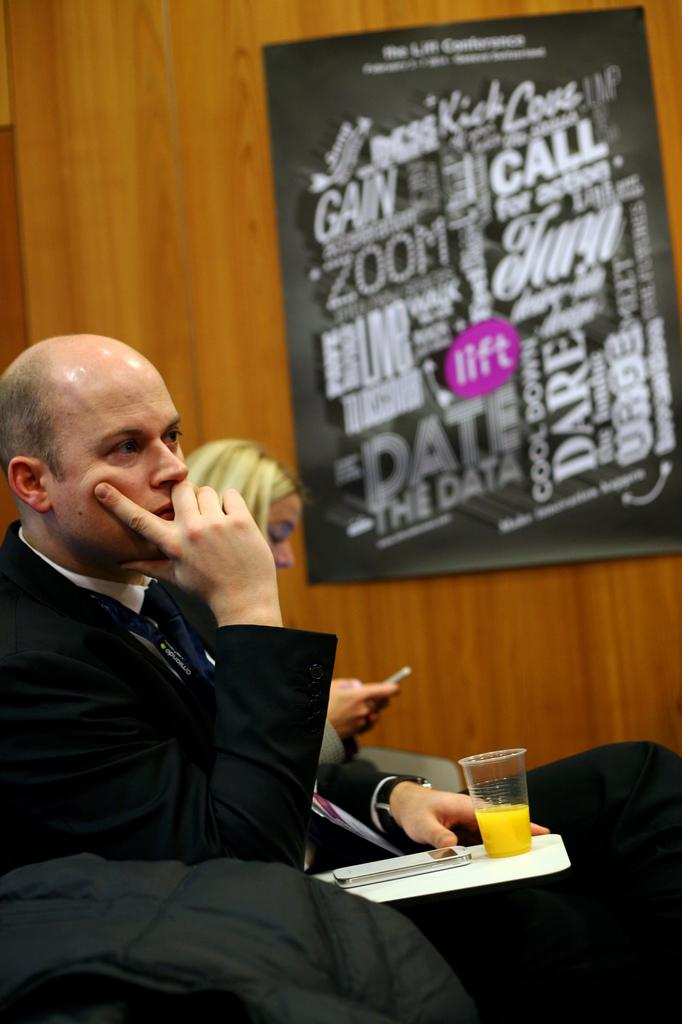<image>
Provide a brief description of the given image. Man sitting behind a poster on the wall with the word "ZOOM" on it. 